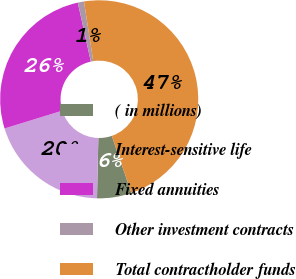<chart> <loc_0><loc_0><loc_500><loc_500><pie_chart><fcel>( in millions)<fcel>Interest-sensitive life<fcel>Fixed annuities<fcel>Other investment contracts<fcel>Total contractholder funds<nl><fcel>5.63%<fcel>19.89%<fcel>26.29%<fcel>1.01%<fcel>47.19%<nl></chart> 